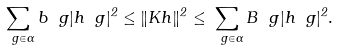<formula> <loc_0><loc_0><loc_500><loc_500>\sum _ { \ g \in \Gamma } b _ { \ } g | h _ { \ } g | ^ { 2 } \leq \| K h \| ^ { 2 } \leq \sum _ { \ g \in \Gamma } B _ { \ } g | h _ { \ } g | ^ { 2 } .</formula> 